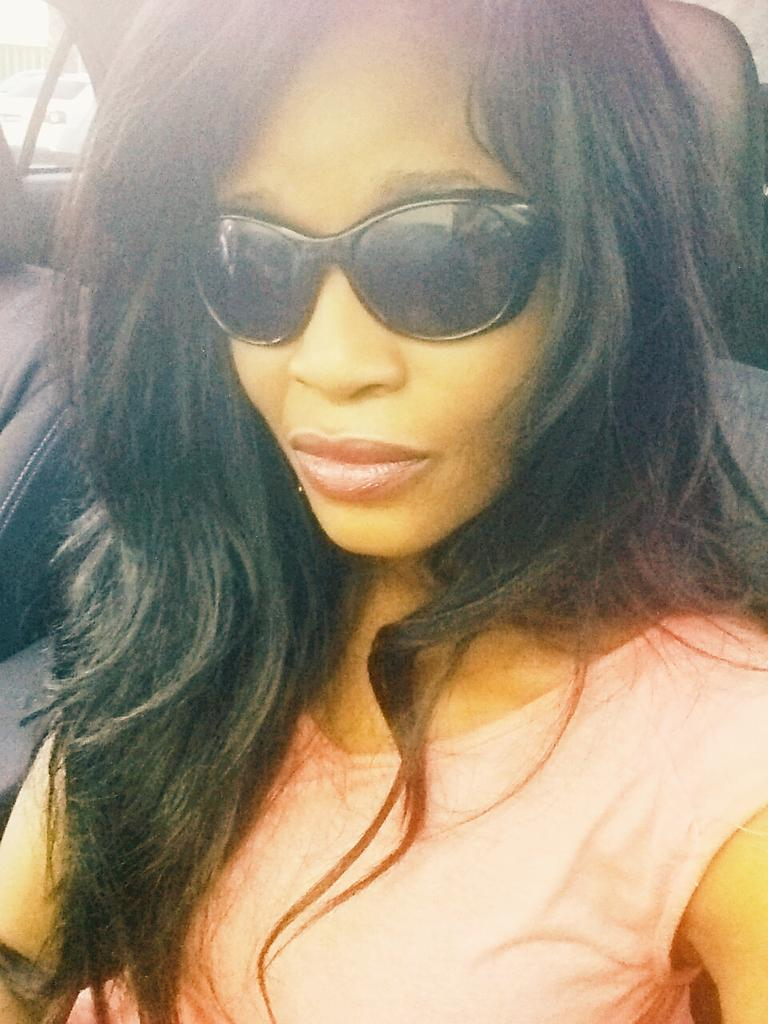Who is present in the image? There is a woman in the image. What is the woman doing in the image? The woman is sitting inside a car. What protective gear is the woman wearing? The woman is wearing goggles. What color is the woman's shirt in the image? The woman is wearing a peach color shirt. What can be seen in the background of the image? There is a window in the backdrop of the image. Is there a man in the image wearing a shirt with a zipper? There is no man present in the image, and no mention of a shirt with a zipper. 